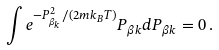<formula> <loc_0><loc_0><loc_500><loc_500>\int e ^ { - P _ { \beta _ { k } } ^ { 2 } / ( 2 m k _ { B } T ) } P _ { \beta k } d P _ { \beta k } = 0 \, .</formula> 